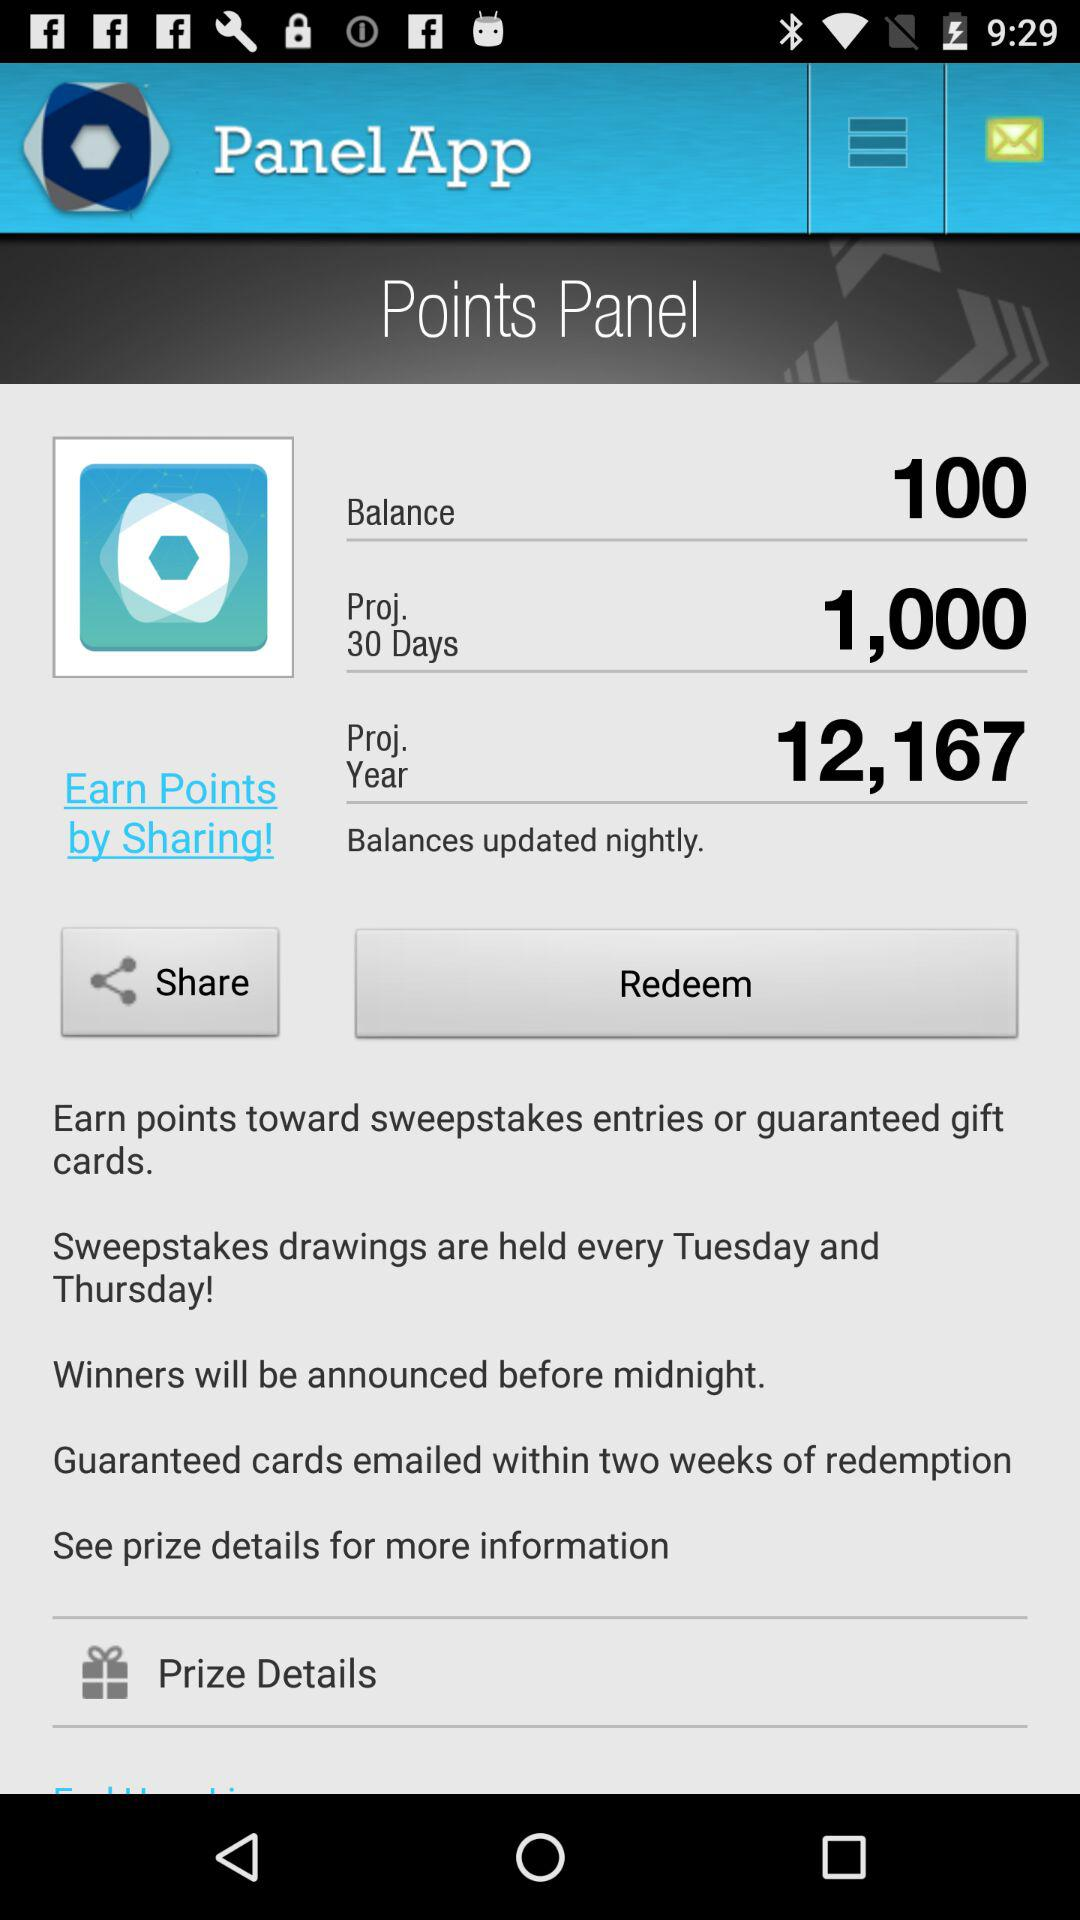Sweepstakes drawings are held on which days? Sweepstakes drawings are held every Tuesday and Thursday. 